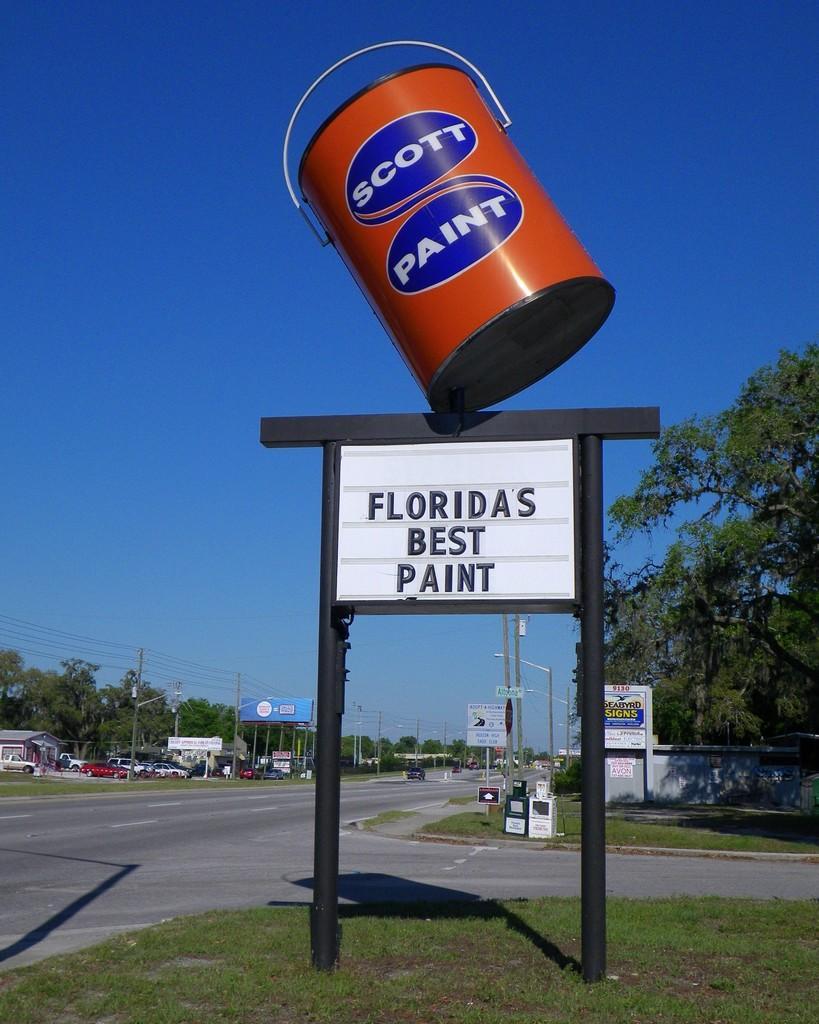Please provide a concise description of this image. In this picture we can see a bucket on a name board, road, grass, vehicles, trees, poles, banners, wires and in the background we can see the sky. 